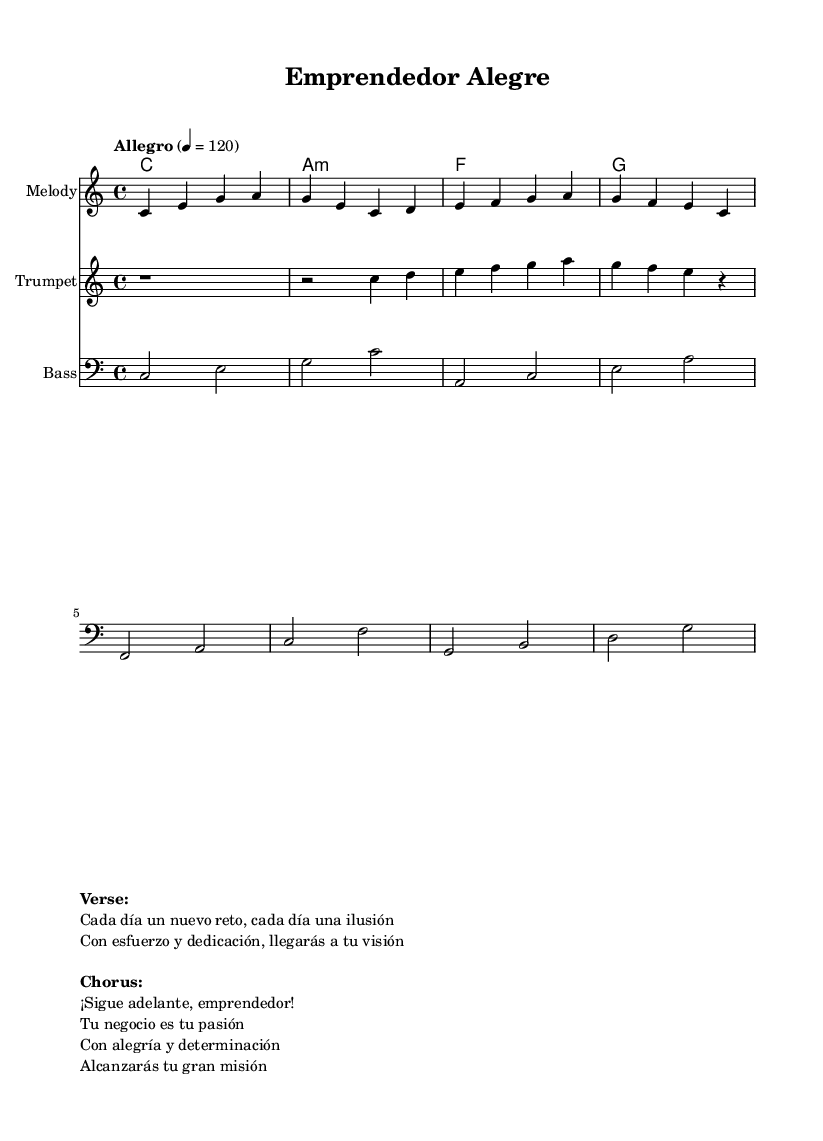What is the key signature of this music? The key signature is C major, which has no sharps or flats.
Answer: C major What is the time signature of this music? The time signature is defined by the 4/4 indication, which means there are four beats in a measure and the quarter note gets one beat.
Answer: 4/4 What is the tempo of the piece? The tempo is indicated as "Allegro" with a metronome marking of 120 beats per minute, suggesting a fast and lively tempo.
Answer: Allegro, 120 How many measures are in the melody section? The melody section consists of 8 measures, as indicated by the rhythmic grouping of notes within the provided stanza.
Answer: 8 What is the first chord played in the harmonies? The first chord shown in the harmonies is C major, which appears in the first measure of the chord progression.
Answer: C What is the primary theme presented in the chorus lyrics? The primary theme in the chorus is motivation and encouragement for entrepreneurs, emphasizing passion and determination in business.
Answer: Motivation How does the trumpet part begin in the score? The trumpet part begins with a rest, indicated by 'r1', which means there is a measure of silence before the notes are played.
Answer: Rest 